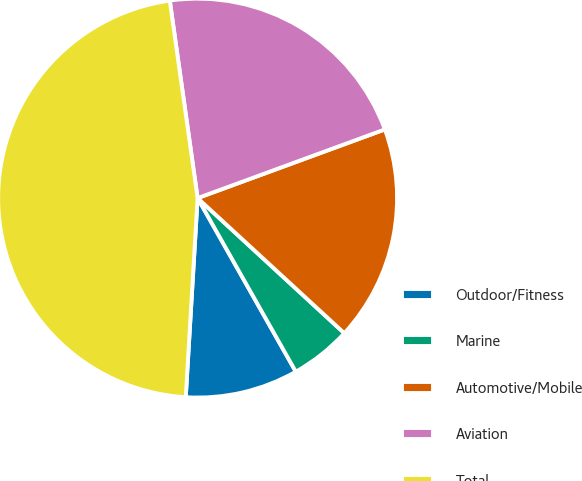Convert chart. <chart><loc_0><loc_0><loc_500><loc_500><pie_chart><fcel>Outdoor/Fitness<fcel>Marine<fcel>Automotive/Mobile<fcel>Aviation<fcel>Total<nl><fcel>9.14%<fcel>4.96%<fcel>17.44%<fcel>21.63%<fcel>46.82%<nl></chart> 